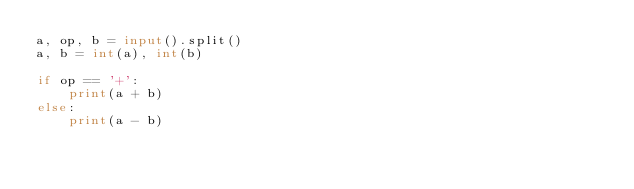Convert code to text. <code><loc_0><loc_0><loc_500><loc_500><_Python_>a, op, b = input().split()
a, b = int(a), int(b)

if op == '+':
    print(a + b)
else:
    print(a - b)
</code> 